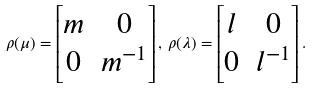<formula> <loc_0><loc_0><loc_500><loc_500>\rho ( \mu ) = \left [ \begin{matrix} m & 0 \\ 0 & m ^ { - 1 } \end{matrix} \right ] , \, \rho ( \lambda ) = \left [ \begin{matrix} l & 0 \\ 0 & l ^ { - 1 } \end{matrix} \right ] .</formula> 